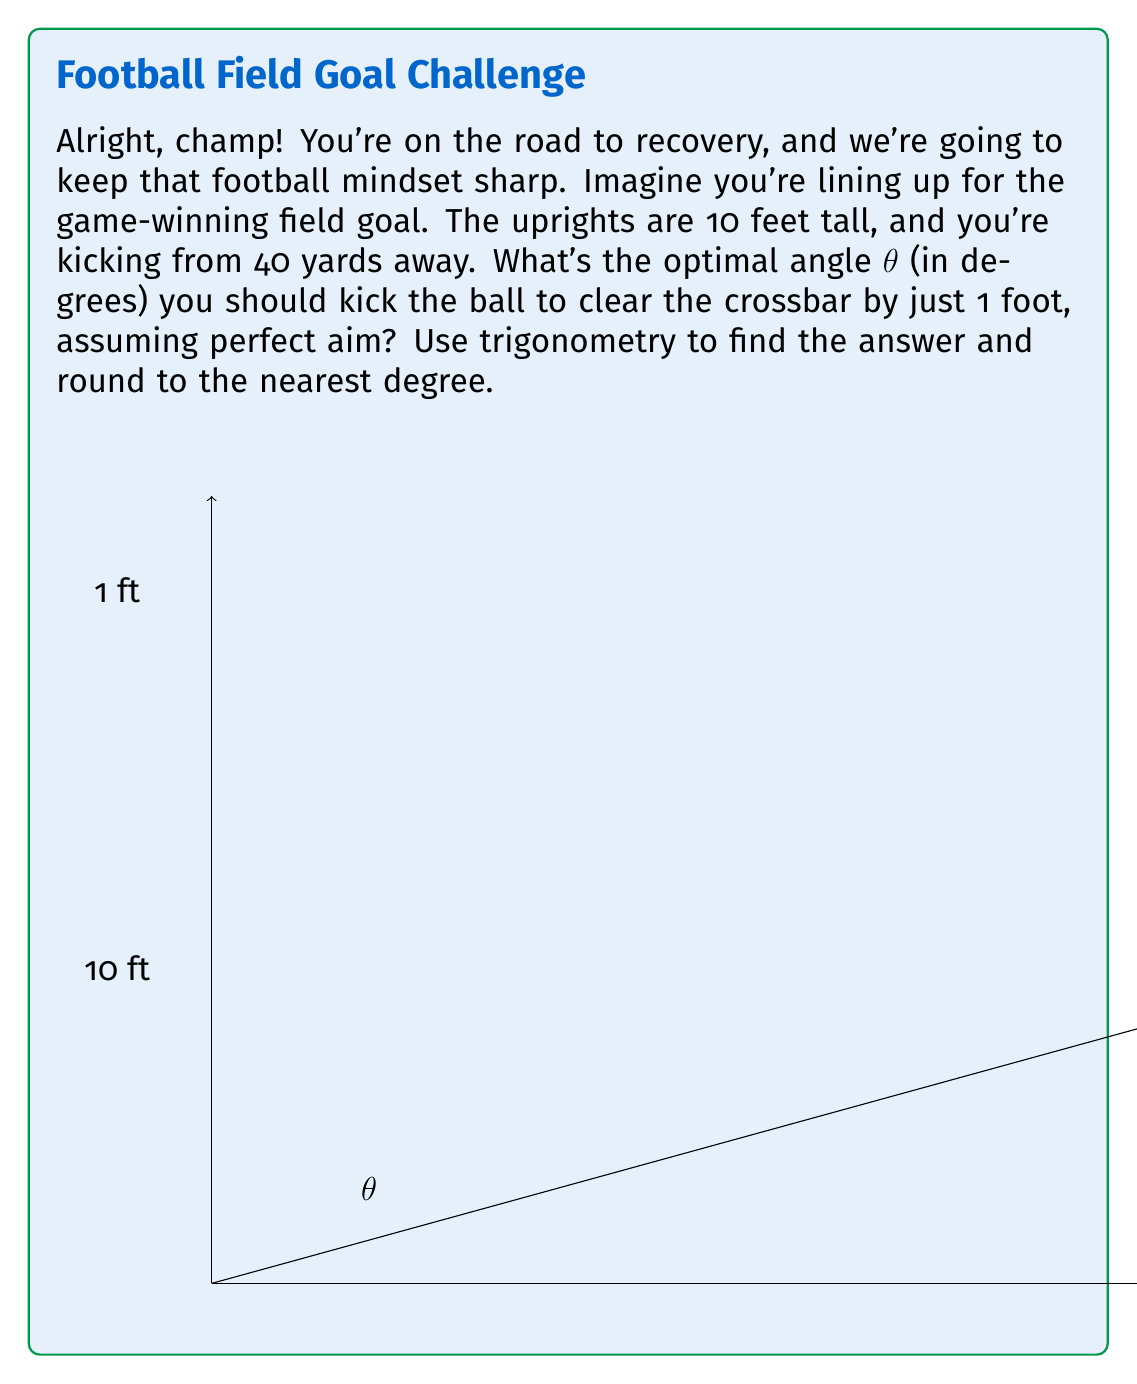Give your solution to this math problem. Let's break this down step-by-step, just like we analyze game footage:

1) First, we need to set up our triangle. The base of our triangle is 40 yards (120 feet), and we want the ball to clear the crossbar by 1 foot, so the top of our triangle is at 11 feet (10 feet for the uprights + 1 foot clearance).

2) We can use the tangent function to find the angle. Tangent is opposite over adjacent:

   $$\tan(\theta) = \frac{\text{opposite}}{\text{adjacent}} = \frac{11}{120}$$

3) To solve for θ, we need to use the inverse tangent (arctan or $\tan^{-1}$):

   $$\theta = \tan^{-1}(\frac{11}{120})$$

4) Using a calculator or computer:

   $$\theta = \tan^{-1}(0.09166667) \approx 5.2318° $$

5) Rounding to the nearest degree:

   $$\theta \approx 5°$$

Remember, in a real game situation, you'd need to account for factors like wind and the rotation of the ball. But this gives you the basic angle to aim for in ideal conditions.
Answer: The optimal angle for the kick is approximately 5°. 